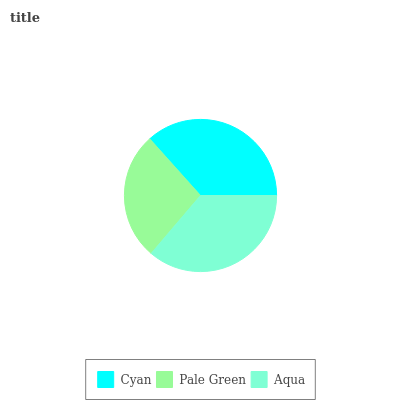Is Pale Green the minimum?
Answer yes or no. Yes. Is Cyan the maximum?
Answer yes or no. Yes. Is Aqua the minimum?
Answer yes or no. No. Is Aqua the maximum?
Answer yes or no. No. Is Aqua greater than Pale Green?
Answer yes or no. Yes. Is Pale Green less than Aqua?
Answer yes or no. Yes. Is Pale Green greater than Aqua?
Answer yes or no. No. Is Aqua less than Pale Green?
Answer yes or no. No. Is Aqua the high median?
Answer yes or no. Yes. Is Aqua the low median?
Answer yes or no. Yes. Is Cyan the high median?
Answer yes or no. No. Is Pale Green the low median?
Answer yes or no. No. 